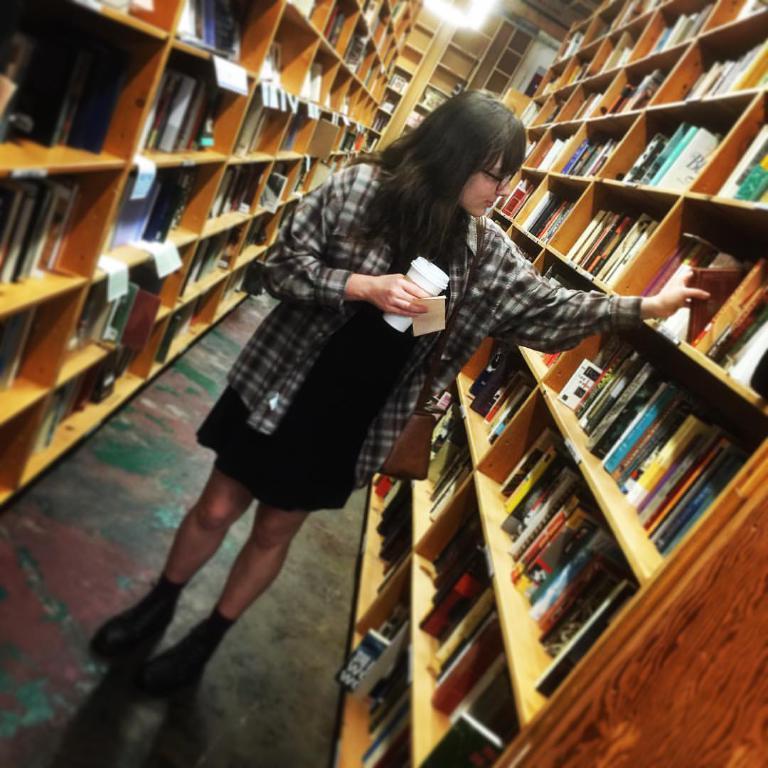Can you describe this image briefly? In the middle of the picture, we see the girl in the black dress is stunning. She is holding a glass in her hands. On either side of the picture, we see racks in which many books are placed. In the background, we see books which are placed in the rack. This picture might be clicked in the library. 